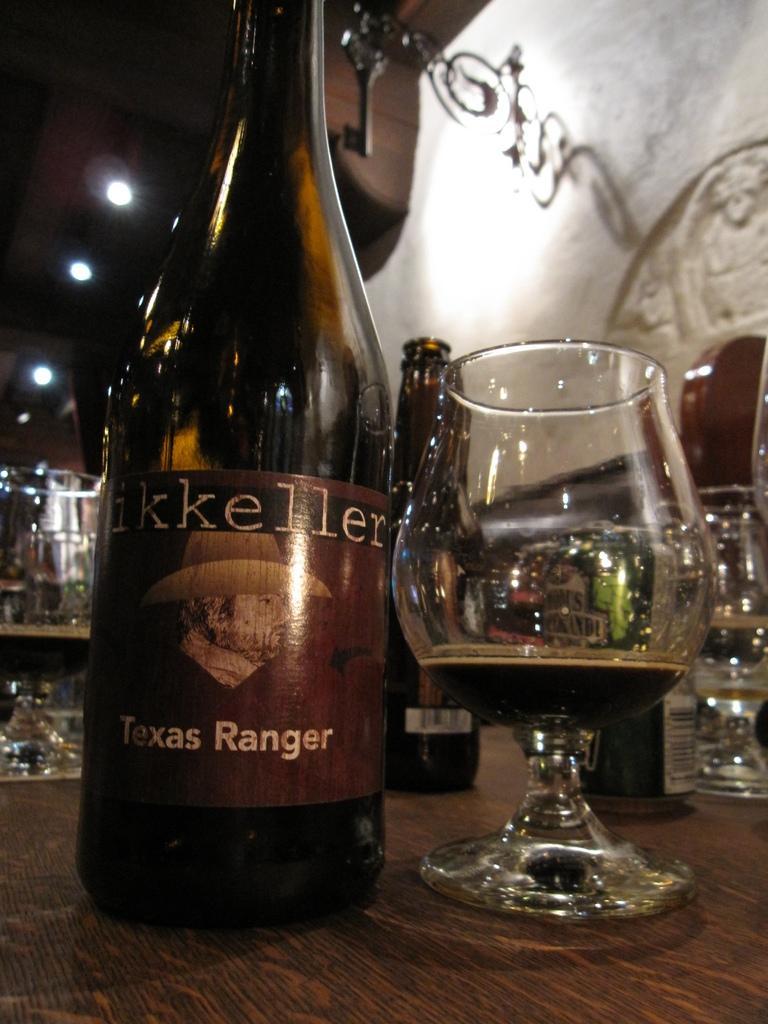Please provide a concise description of this image. In this image we can see some bottles and glasses with beer which are placed on the table. On the backside we can see a decal to a wall and some ceiling lights. 